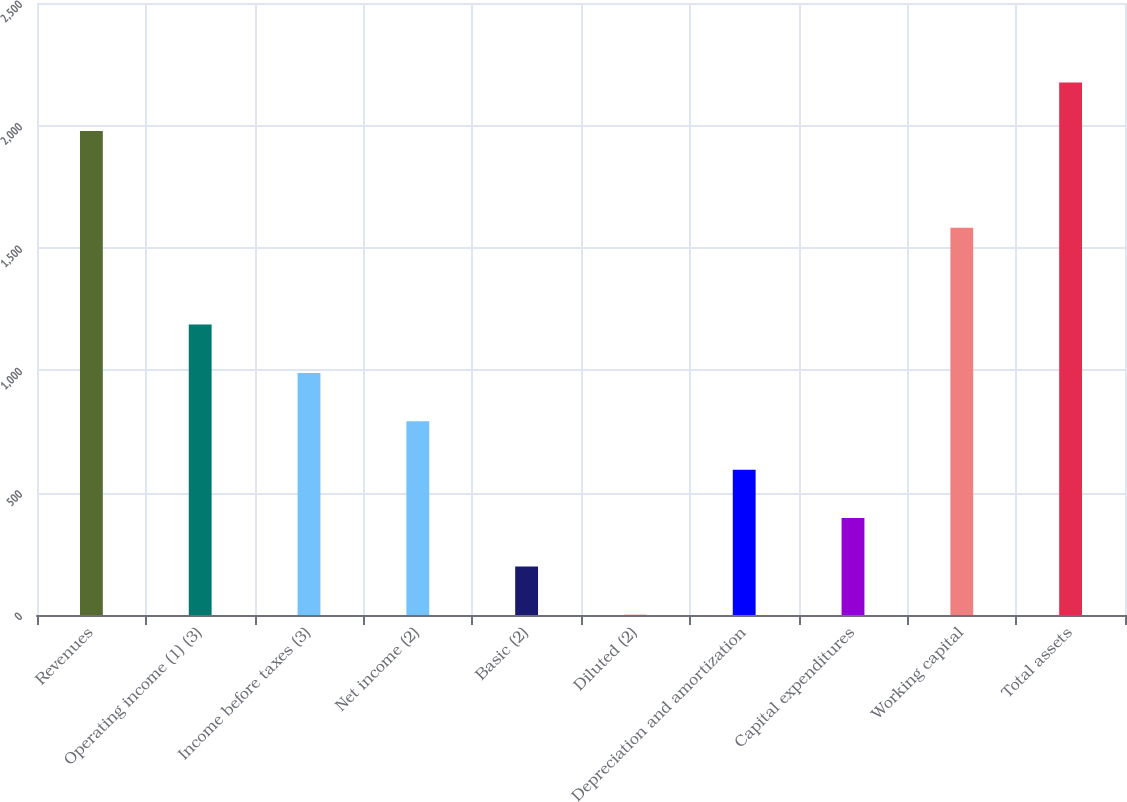Convert chart. <chart><loc_0><loc_0><loc_500><loc_500><bar_chart><fcel>Revenues<fcel>Operating income (1) (3)<fcel>Income before taxes (3)<fcel>Net income (2)<fcel>Basic (2)<fcel>Diluted (2)<fcel>Depreciation and amortization<fcel>Capital expenditures<fcel>Working capital<fcel>Total assets<nl><fcel>1977.19<fcel>1186.67<fcel>989.04<fcel>791.41<fcel>198.52<fcel>0.89<fcel>593.78<fcel>396.15<fcel>1581.93<fcel>2174.82<nl></chart> 